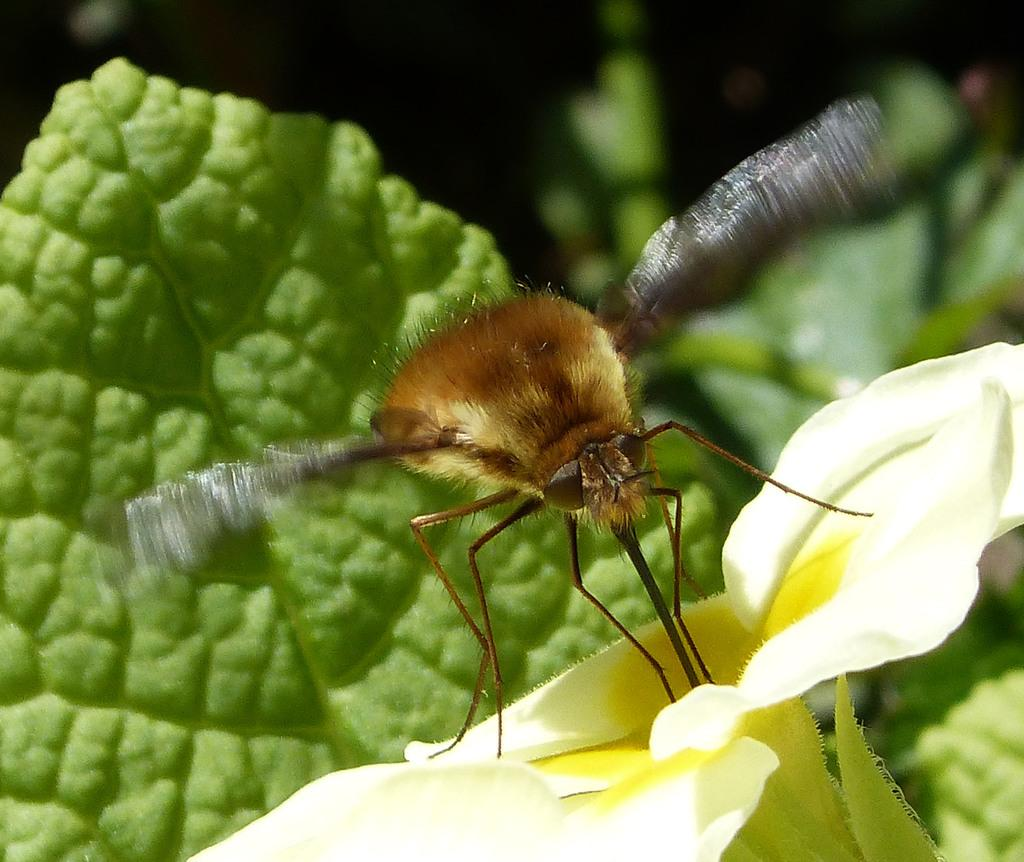What is the insect sitting on in the image? There is an insect on a yellow flower in the image. What type of plant is visible in the image? There are flowers on a plant in the image. Can you describe the background of the image? The background of the image is blurry. What type of basket is hanging from the insect's nose in the image? There is no basket or insect's nose present in the image; it features an insect on a yellow flower and flowers on a plant. 